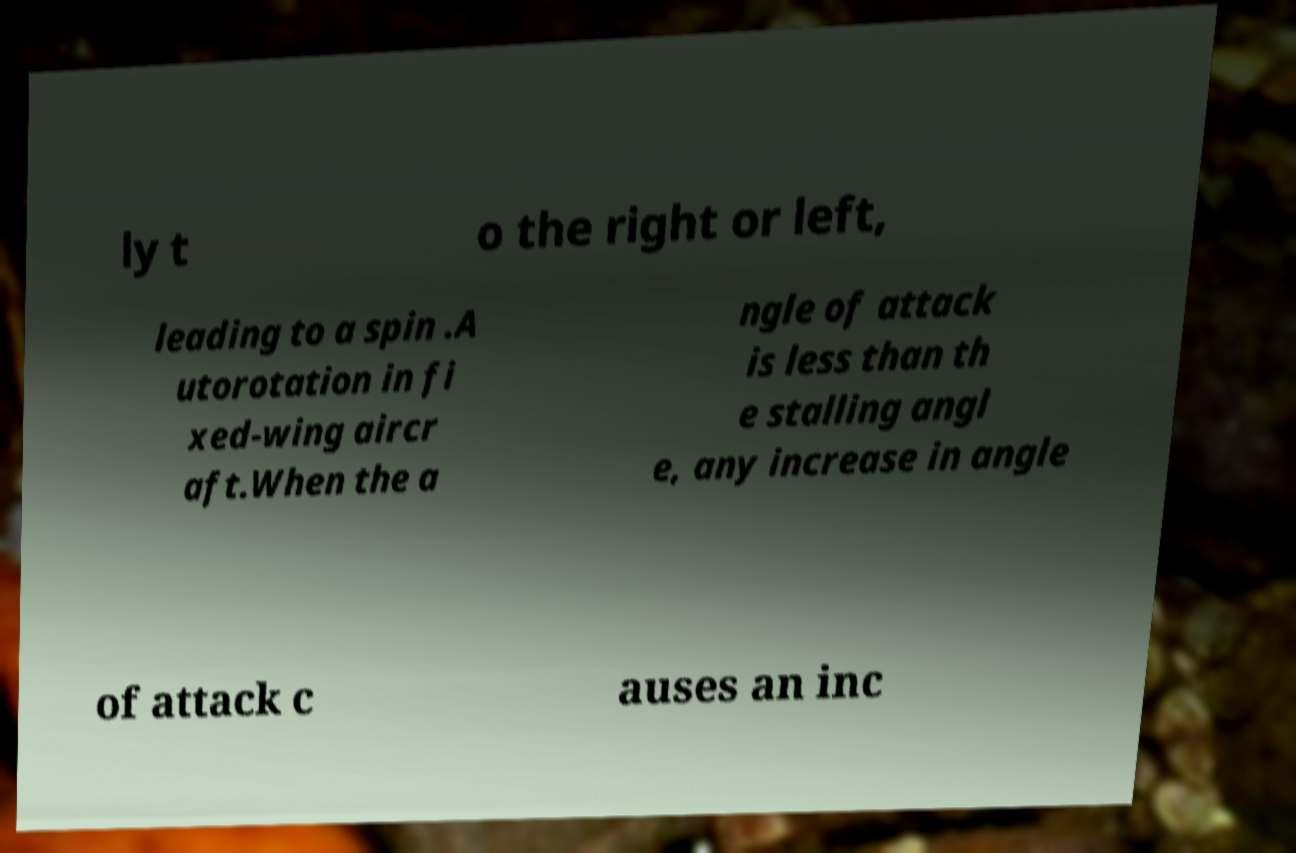What messages or text are displayed in this image? I need them in a readable, typed format. ly t o the right or left, leading to a spin .A utorotation in fi xed-wing aircr aft.When the a ngle of attack is less than th e stalling angl e, any increase in angle of attack c auses an inc 